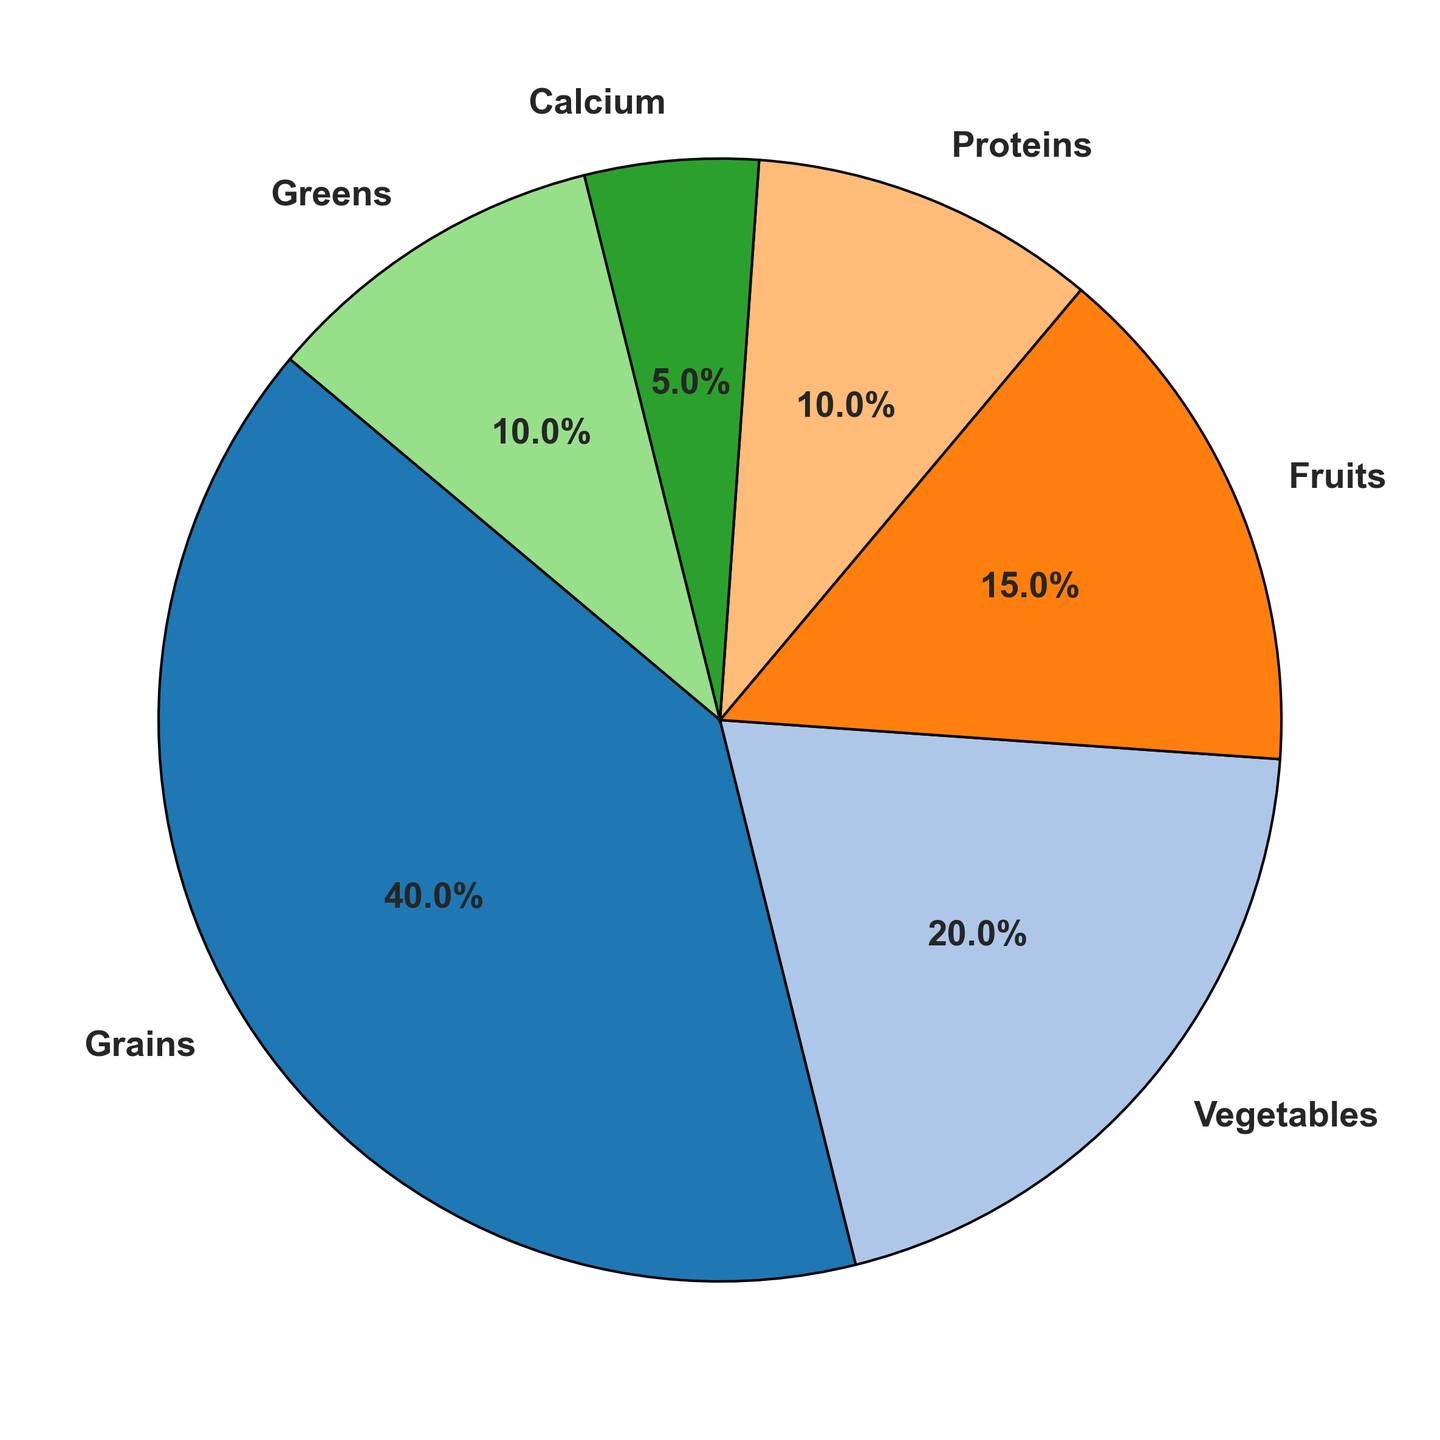What is the most prominent source of nutrition in your chickens' diet? To find the most prominent source of nutrition, look for the category with the largest percentage in the pie chart. Here, the largest wedge represents 'Grains' with 40%.
Answer: Grains How much more percentage is dedicated to grains than to proteins? First, note the percentages for 'Grains' and 'Proteins'. Grains have 40%, and Proteins have 10%. Subtract the percentage of Proteins from Grains: 40% - 10% = 30%.
Answer: 30% Which sources of nutrition each account for 10%? Identify the wedges labeled with 10% in the pie chart. The categories labeled with 10% are 'Proteins' and 'Greens'.
Answer: Proteins and Greens Combine the percentage of fruits and vegetables. How does it compare to the percentage of grains? Add the percentages of 'Fruits' and 'Vegetables': 15% + 20% = 35%. Then compare it to the percentage of 'Grains', which is 40%. 35% < 40%, so the combined percentage of fruits and vegetables is less than that of grains.
Answer: Less than What is the combined percentage of calcium and greens? To find the combined percentage, sum up 'Calcium' and 'Greens': 5% + 10% = 15%.
Answer: 15% What category has the smallest contribution, and what is that percentage? Look for the smallest wedge in the pie chart, which represents the category with the smallest contribution. This category is 'Calcium' with 5%.
Answer: Calcium, 5% Which categories total 50% together? Find two or more categories that add up to 50%. 'Vegetables' and 'Grains' together total 20% + 40% = 60%, which is too much. 'Vegetables', 'Fruits', and 'Proteins' total 20% + 15% + 10% = 45%, which is less. 'Vegetables' and 'Fruits' together make 20% + 15% = 35%. 'Proteins' and 'Greens' together make 10% + 10% = 20%. By adding 'Grains' and 'Proteins': 40% + 10% = 50%.
Answer: Grains and Proteins Is the proportion of fruits greater than the combined proportion of calcium and greens? Check the percentage for 'Fruits', which is 15%, and compare it to the combined proportion of 'Calcium' and 'Greens', which is 5% + 10% = 15%. Both are equal, making the proportion not greater.
Answer: No Which source of nutrition has twice the percentage of fruits? 'Fruits' are 15%. Look for a category that has twice this amount, which is 30%. No category has exactly 30%. Therefore, no single category fits this requirement.
Answer: None What is the total percentage of grains, vegetables, and greens combined? Add the percentages of 'Grains', 'Vegetables', and 'Greens': 40% + 20% + 10%, which totals 70%.
Answer: 70% 